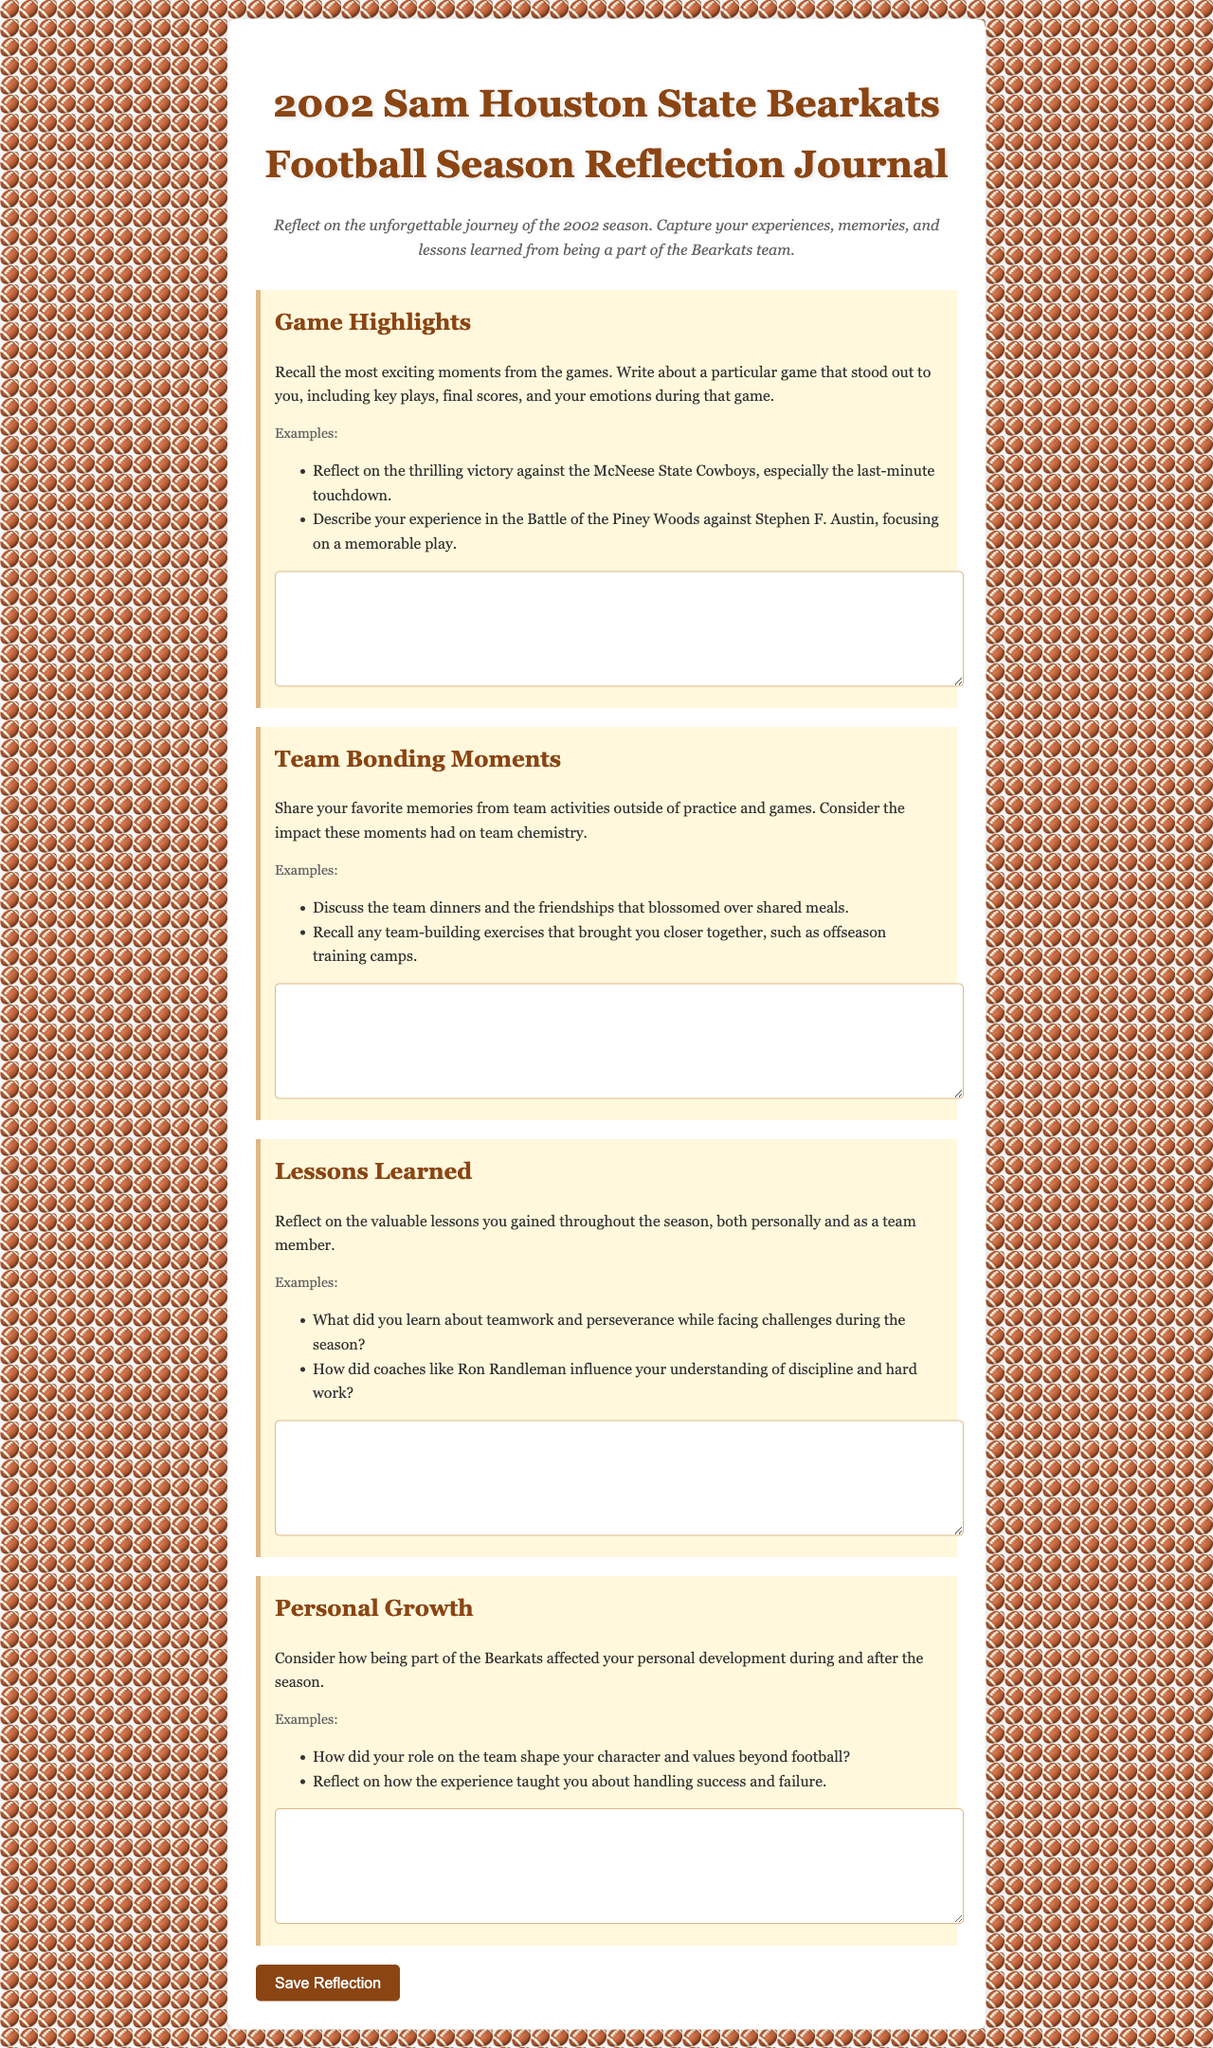What is the title of the document? The title of the document is found at the top and provides the main focus of the content.
Answer: 2002 Sam Houston State Bearkats Football Season Reflection Journal How many main prompts are included in the reflection journal? The prompts are listed in separate sections, and counting them provides the total number.
Answer: 4 What color is the background of the document? The background color of the document can be described based on the styling mentioned in the code.
Answer: light gray What is one example of a game highlight mentioned in the prompts? The document lists examples under each prompt, providing a specific case to reflect upon.
Answer: thrilling victory against the McNeese State Cowboys What lesson does the document mention regarding teamwork? Referring to the lessons learned section reveals insights about teamwork and personal growth.
Answer: teamwork and perseverance What is the purpose of the reflection journal? The document's introduction briefly states the objective of its content and engagement.
Answer: Reflect on the unforgettable journey of the 2002 season What format is used for the text area inputs? The document specifies the type of input fields used for responses within the form.
Answer: text area What is the significance of the button at the bottom of the form? The button provides an action for the user to submit their reflections, highlighting user interaction.
Answer: Save Reflection 